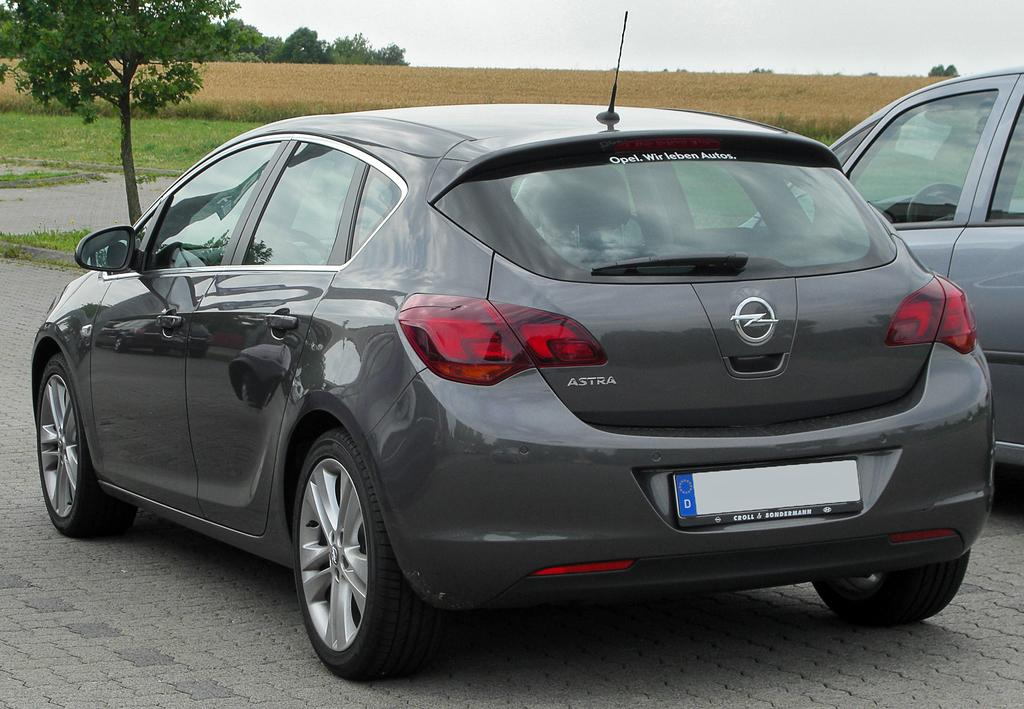What is located on the pavement in the image? There are vehicles on the pavement in the image. What can be seen in the background of the image? There are fields, trees, and the sky visible in the background of the image. What type of jewel can be seen sparkling in the fields in the image? There is no jewel present in the image; it features vehicles on a pavement and fields, trees, and the sky in the background. How many chickens are visible in the image? There are no chickens present in the image. 